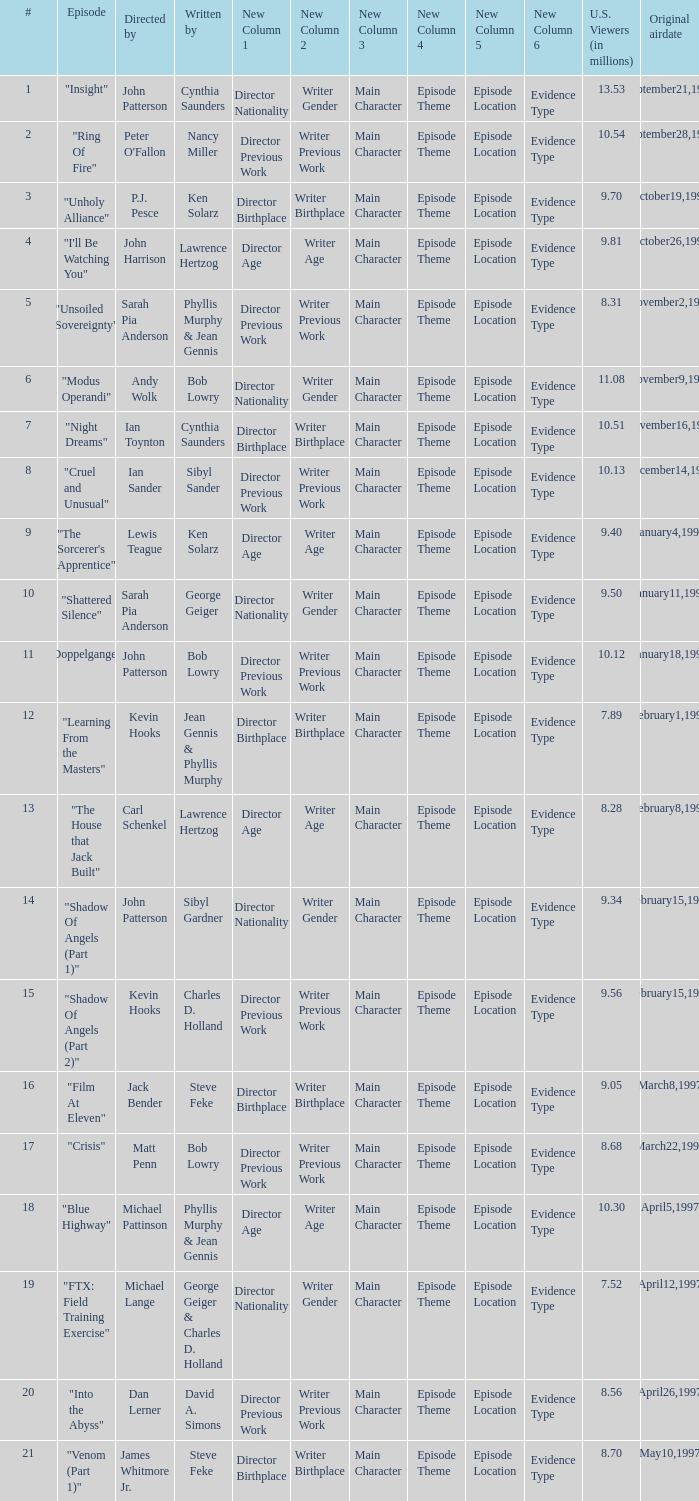Who wrote the episode with 9.81 million US viewers? Lawrence Hertzog. 